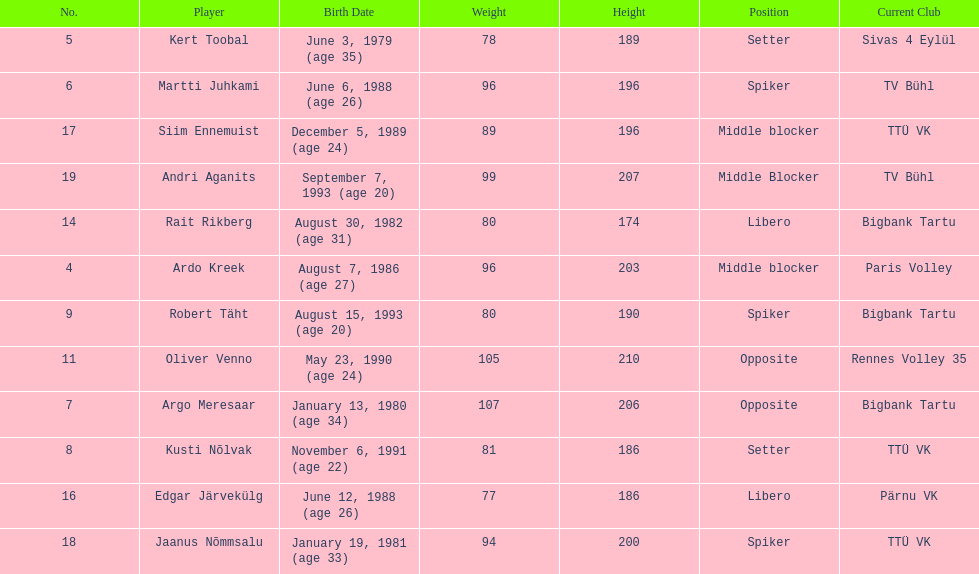Who is at least 25 years or older? Ardo Kreek, Kert Toobal, Martti Juhkami, Argo Meresaar, Rait Rikberg, Edgar Järvekülg, Jaanus Nõmmsalu. Would you mind parsing the complete table? {'header': ['No.', 'Player', 'Birth Date', 'Weight', 'Height', 'Position', 'Current Club'], 'rows': [['5', 'Kert Toobal', 'June 3, 1979 (age\xa035)', '78', '189', 'Setter', 'Sivas 4 Eylül'], ['6', 'Martti Juhkami', 'June 6, 1988 (age\xa026)', '96', '196', 'Spiker', 'TV Bühl'], ['17', 'Siim Ennemuist', 'December 5, 1989 (age\xa024)', '89', '196', 'Middle blocker', 'TTÜ VK'], ['19', 'Andri Aganits', 'September 7, 1993 (age\xa020)', '99', '207', 'Middle Blocker', 'TV Bühl'], ['14', 'Rait Rikberg', 'August 30, 1982 (age\xa031)', '80', '174', 'Libero', 'Bigbank Tartu'], ['4', 'Ardo Kreek', 'August 7, 1986 (age\xa027)', '96', '203', 'Middle blocker', 'Paris Volley'], ['9', 'Robert Täht', 'August 15, 1993 (age\xa020)', '80', '190', 'Spiker', 'Bigbank Tartu'], ['11', 'Oliver Venno', 'May 23, 1990 (age\xa024)', '105', '210', 'Opposite', 'Rennes Volley 35'], ['7', 'Argo Meresaar', 'January 13, 1980 (age\xa034)', '107', '206', 'Opposite', 'Bigbank Tartu'], ['8', 'Kusti Nõlvak', 'November 6, 1991 (age\xa022)', '81', '186', 'Setter', 'TTÜ VK'], ['16', 'Edgar Järvekülg', 'June 12, 1988 (age\xa026)', '77', '186', 'Libero', 'Pärnu VK'], ['18', 'Jaanus Nõmmsalu', 'January 19, 1981 (age\xa033)', '94', '200', 'Spiker', 'TTÜ VK']]} 